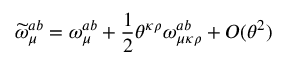Convert formula to latex. <formula><loc_0><loc_0><loc_500><loc_500>\widetilde { \omega } _ { \mu } ^ { a b } = \omega _ { \mu } ^ { a b } + \frac { 1 } { 2 } \theta ^ { \kappa \rho } \omega _ { \mu \kappa \rho } ^ { a b } + O ( \theta ^ { 2 } )</formula> 